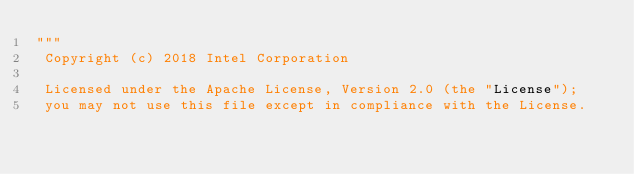<code> <loc_0><loc_0><loc_500><loc_500><_Python_>"""
 Copyright (c) 2018 Intel Corporation

 Licensed under the Apache License, Version 2.0 (the "License");
 you may not use this file except in compliance with the License.</code> 